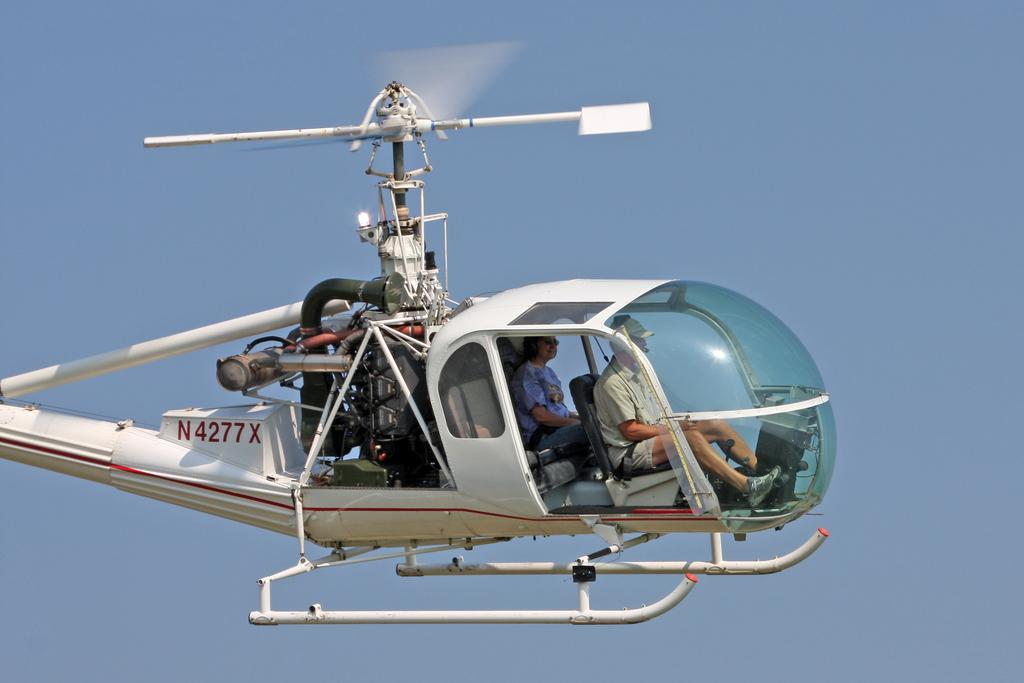<image>
Describe the image concisely. A helicopter with the letter N in red on the back 